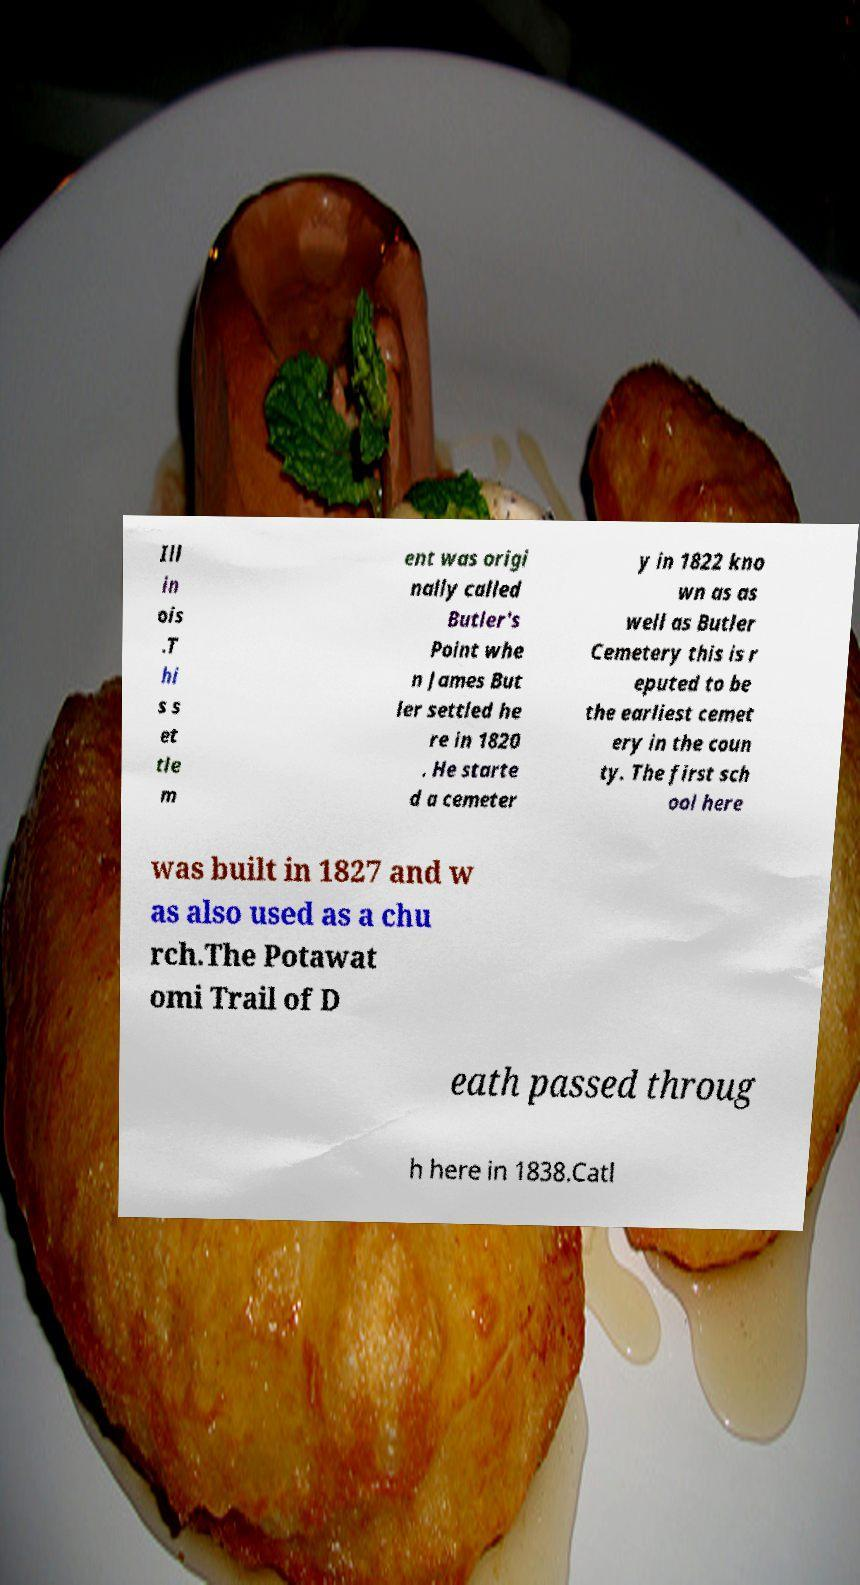For documentation purposes, I need the text within this image transcribed. Could you provide that? Ill in ois .T hi s s et tle m ent was origi nally called Butler's Point whe n James But ler settled he re in 1820 . He starte d a cemeter y in 1822 kno wn as as well as Butler Cemetery this is r eputed to be the earliest cemet ery in the coun ty. The first sch ool here was built in 1827 and w as also used as a chu rch.The Potawat omi Trail of D eath passed throug h here in 1838.Catl 